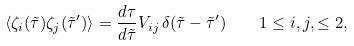Convert formula to latex. <formula><loc_0><loc_0><loc_500><loc_500>\langle \zeta _ { i } ( \tilde { \tau } ) \zeta _ { j } ( \tilde { \tau } ^ { \prime } ) \rangle = \frac { d \tau } { d \tilde { \tau } } V _ { i j } \, \delta ( \tilde { \tau } - \tilde { \tau } ^ { \prime } ) \quad 1 \leq i , j , \leq 2 ,</formula> 